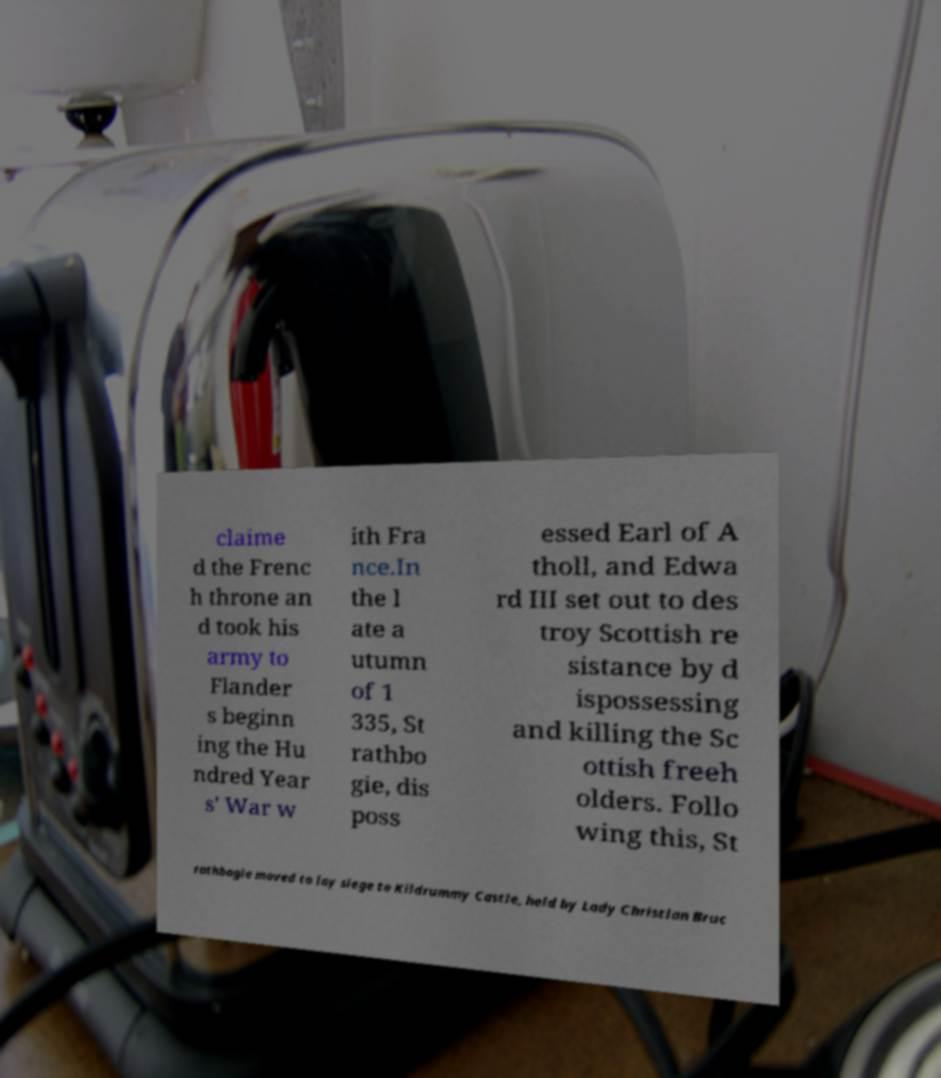There's text embedded in this image that I need extracted. Can you transcribe it verbatim? claime d the Frenc h throne an d took his army to Flander s beginn ing the Hu ndred Year s' War w ith Fra nce.In the l ate a utumn of 1 335, St rathbo gie, dis poss essed Earl of A tholl, and Edwa rd III set out to des troy Scottish re sistance by d ispossessing and killing the Sc ottish freeh olders. Follo wing this, St rathbogie moved to lay siege to Kildrummy Castle, held by Lady Christian Bruc 